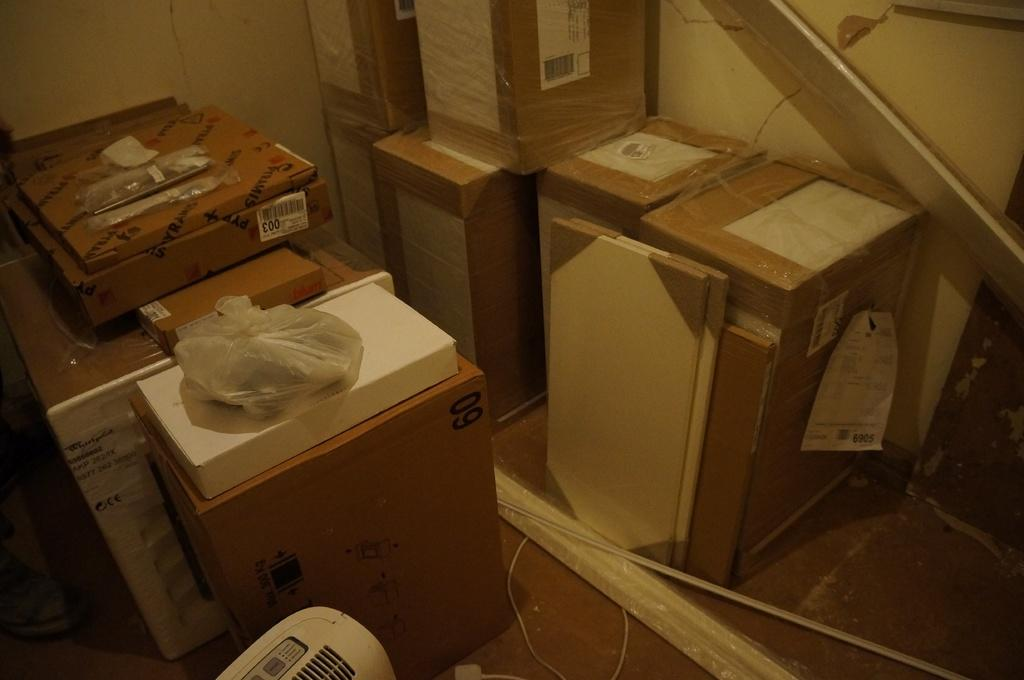What type of containers are present in the image? There are sealed cardboard boxes in the image. What other objects can be seen in the image? There are boards visible in the image. What is visible in the background of the image? There is a wall in the background of the image. What type of field can be seen growing in the image? There is no field present in the image; it features sealed cardboard boxes and boards. What type of knot is used to secure the cardboard boxes in the image? The cardboard boxes are sealed, so there is no knot present. What type of vein can be seen running through the boards in the image? There are no veins visible in the image; it features sealed cardboard boxes and boards. 